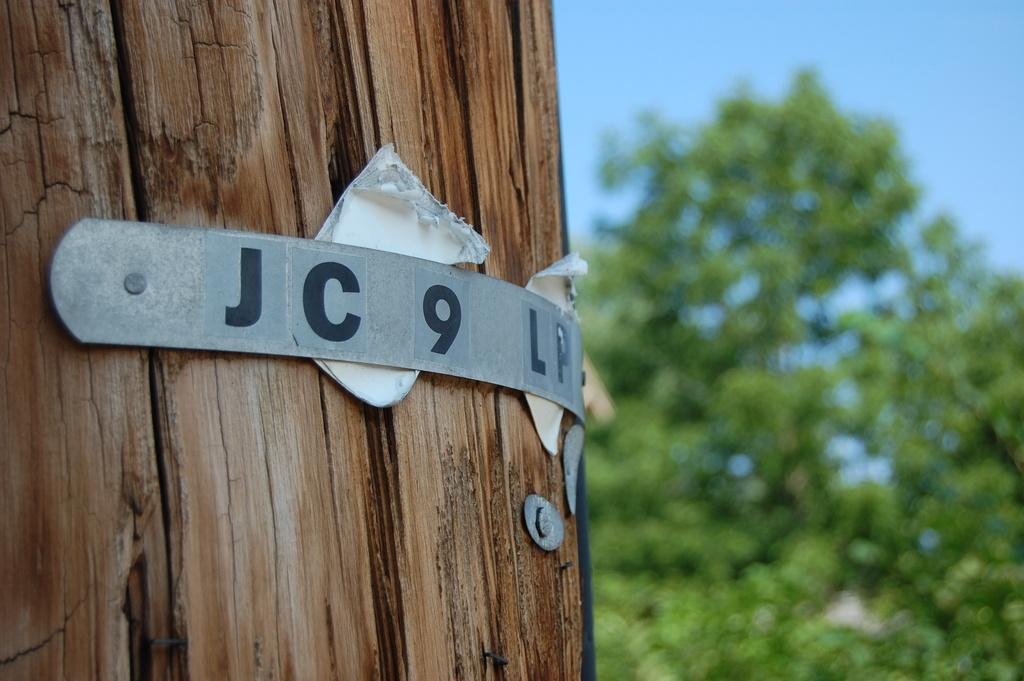What object is located on the left side of the image? There is a trunk on the left side of the image. What is attached to the trunk? A metal board is attached to the trunk. What is placed on the metal board? Papers are attached to the metal board. What can be seen in the background of the image? There is a tree in the background of the image. What is visible at the top of the image? The sky is visible at the top of the image. Where is the needle used by the aunt in the image? There is no needle or aunt present in the image. What type of cup is being used by the person in the image? There is no cup or person present in the image. 